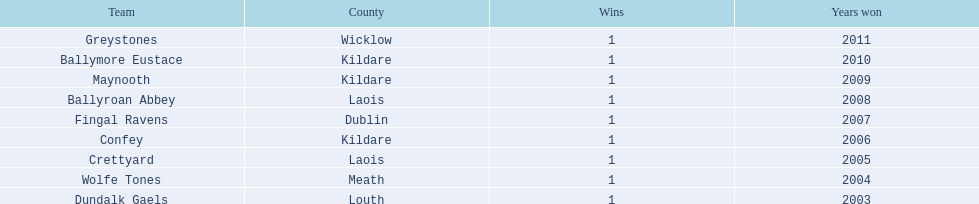Which county holds the record for the most wins? Kildare. 